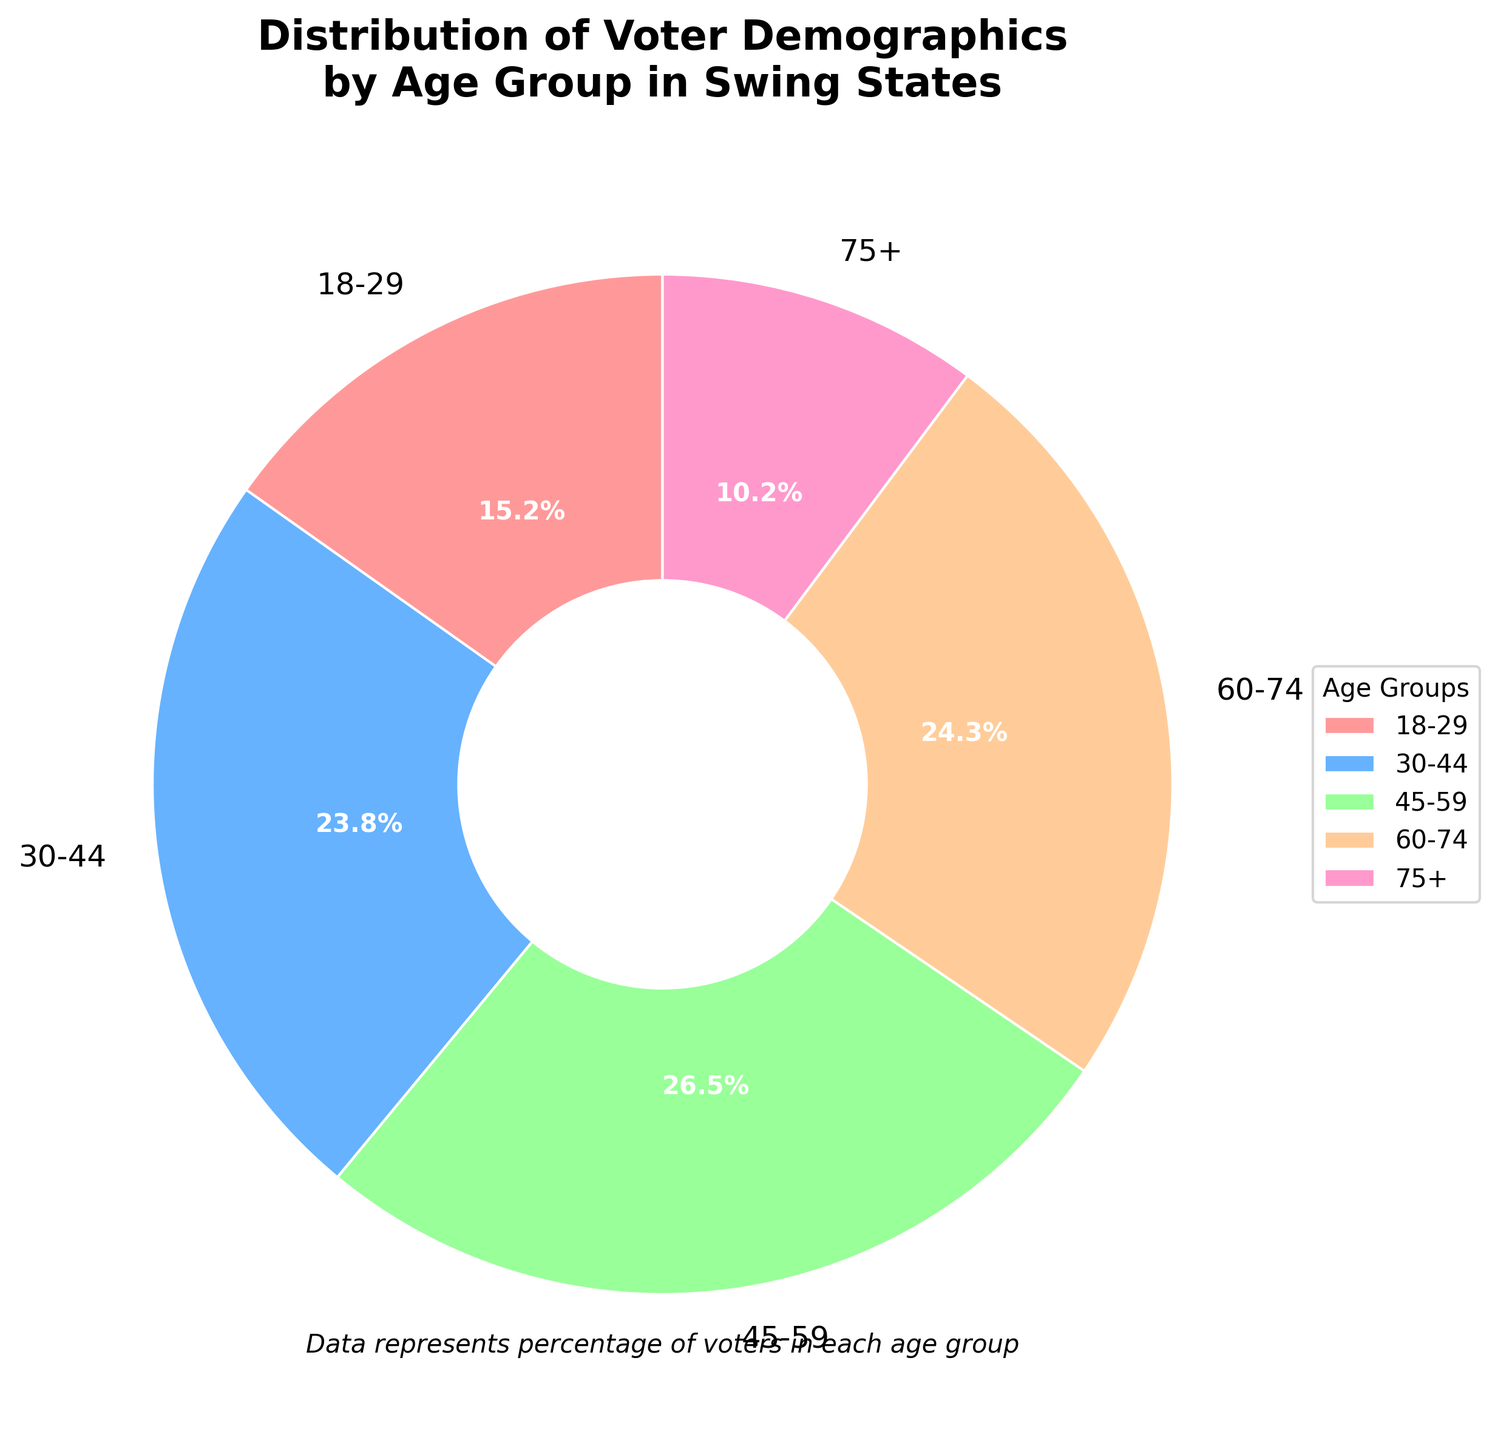What percentage of voters are in the 45-59 age group? The figure shows the 45-59 age group occupying a specific portion of the pie chart labeled with its percentage.
Answer: 26.5% Which age group has the smallest percentage of voters? By visually examining the pie chart, we can identify the age group with the smallest slice, which is labeled accordingly.
Answer: 75+ What is the combined percentage of voters in the 60-74 and 75+ age groups? Add the percentages of the two specified age groups: 24.3% (60-74) and 10.2% (75+). So, the combined percentage is 24.3 + 10.2 = 34.5%.
Answer: 34.5% Is the percentage of voters aged 18-29 greater than those aged 75+? Visually compare the slices for the 18-29 and 75+ age groups, noting the labeled percentages of 15.2% and 10.2%, respectively.
Answer: Yes Which age group has a percentage closest to 25%? Identify the age group slices and their respective percentages. The 60-74 age group with 24.3% is the closest to 25%.
Answer: 60-74 How much more percentage of voters are there in the 45-59 age group compared to the 18-29 age group? Subtract the percentage of the 18-29 age group (15.2%) from the percentage of the 45-59 age group (26.5%): 26.5 - 15.2 = 11.3%.
Answer: 11.3% List the age groups in descending order based on their percentage of voters. Arrange the age groups from highest to lowest based on their labeled percentages: 45-59 (26.5%), 60-74 (24.3%), 30-44 (23.8%), 18-29 (15.2%), 75+ (10.2%).
Answer: 45-59, 60-74, 30-44, 18-29, 75+ Which age group occupies the second-largest segment in the pie chart? The second-largest segment by visual inspection and labeled percentage is the 60-74 age group with 24.3%.
Answer: 60-74 Are there more voters in the 30-44 age group or the 60-74 age group? Compare the labeled percentages: 23.8% (30-44) with 24.3% (60-74). The 60-74 age group has a slightly larger percentage.
Answer: 60-74 What percentage of voters are below the age of 45? Sum the percentages of all age groups below 45: (18-29) 15.2% + (30-44) 23.8% = 39.0%.
Answer: 39.0% 